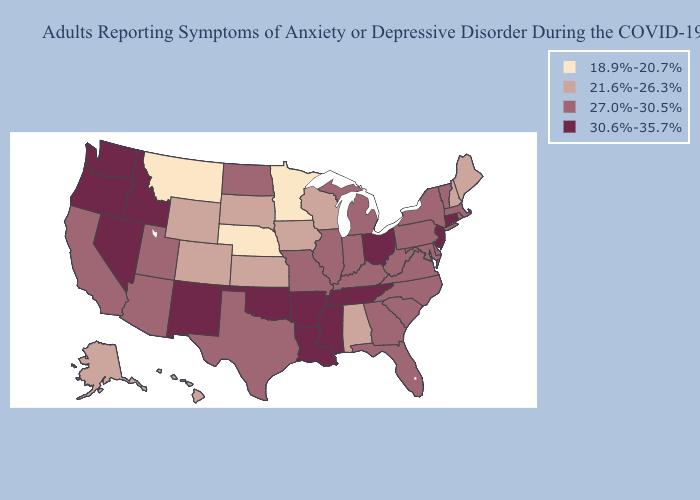Is the legend a continuous bar?
Short answer required. No. Name the states that have a value in the range 30.6%-35.7%?
Keep it brief. Arkansas, Connecticut, Idaho, Louisiana, Mississippi, Nevada, New Jersey, New Mexico, Ohio, Oklahoma, Oregon, Tennessee, Washington. Does Oklahoma have the same value as Hawaii?
Answer briefly. No. How many symbols are there in the legend?
Keep it brief. 4. Does Arkansas have a higher value than Kentucky?
Keep it brief. Yes. Among the states that border Iowa , which have the highest value?
Concise answer only. Illinois, Missouri. Which states have the highest value in the USA?
Concise answer only. Arkansas, Connecticut, Idaho, Louisiana, Mississippi, Nevada, New Jersey, New Mexico, Ohio, Oklahoma, Oregon, Tennessee, Washington. Name the states that have a value in the range 18.9%-20.7%?
Concise answer only. Minnesota, Montana, Nebraska. Does Mississippi have the highest value in the USA?
Keep it brief. Yes. What is the highest value in states that border Kentucky?
Quick response, please. 30.6%-35.7%. Among the states that border Louisiana , does Texas have the highest value?
Short answer required. No. What is the highest value in the South ?
Short answer required. 30.6%-35.7%. Among the states that border Louisiana , does Arkansas have the lowest value?
Write a very short answer. No. What is the value of Alaska?
Quick response, please. 21.6%-26.3%. What is the value of Vermont?
Keep it brief. 27.0%-30.5%. 